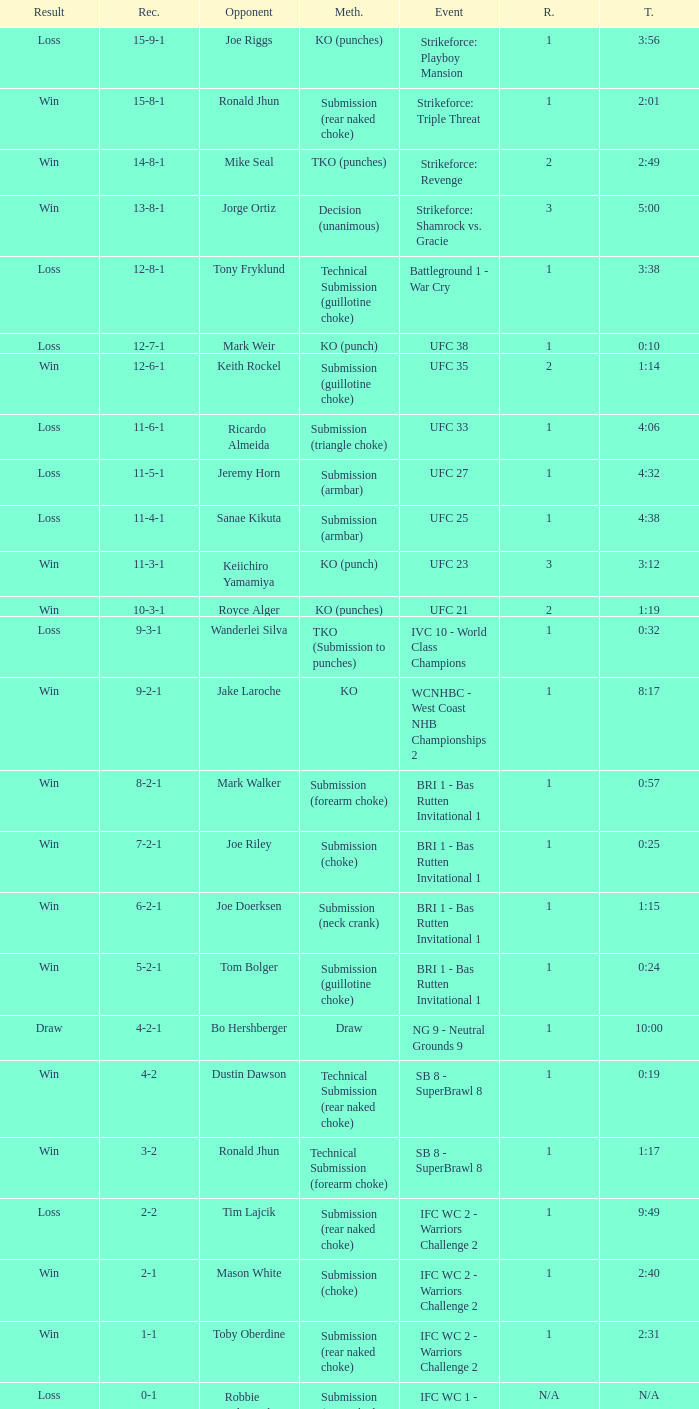Who was the opponent when the fight had a time of 2:01? Ronald Jhun. 